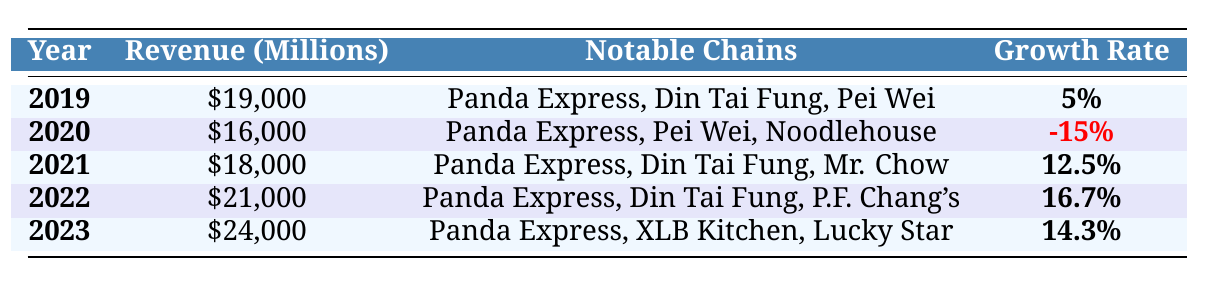What was the revenue of Chinese restaurants in 2021? In the table, under the year 2021, the revenue is stated as \$18,000 million.
Answer: \$18,000 million Which year had the highest revenue? By examining the table, the revenue of \$24,000 million in 2023 is greater than the revenues listed for the other years.
Answer: 2023 What was the growth rate in 2020? The table shows that the growth rate for the year 2020 is marked as -15%.
Answer: -15% Did the revenue increase every year from 2019 to 2023? Looking at the revenue figures, 2020 shows a decrease from 2019, indicating that the revenue did not increase every year.
Answer: No What was the total revenue of Chinese restaurants from 2019 to 2023? The total revenue can be calculated by summing the revenues: \$19,000 + \$16,000 + \$18,000 + \$21,000 + \$24,000 = \$98,000 million.
Answer: \$98,000 million Which notable chain appeared consistently from 2019 to 2023? By analyzing the notable chains listed for each year, Panda Express is mentioned in every year from 2019 to 2023.
Answer: Panda Express What was the average growth rate from 2019 to 2023? The growth rates are: 5%, -15%, 12.5%, 16.7%, and 14.3%. Their average is calculated as (5 + (-15) + 12.5 + 16.7 + 14.3) / 5 = 6.9%.
Answer: 6.9% In which year did the revenue increase the most compared to the previous year? By comparing year-to-year revenue changes, the increase from \$18,000 in 2021 to \$21,000 in 2022 amounts to \$3,000, which is the largest increase in the table.
Answer: 2022 Was 2022 the year with the highest growth rate? In the table, the year 2022 has a growth rate of 16.7%, which is higher than the other years.
Answer: Yes What was the difference in revenue between 2019 and 2020? The revenue in 2019 was \$19,000 million and in 2020 it was \$16,000 million. The difference is \$19,000 - \$16,000 = \$3,000 million.
Answer: \$3,000 million 